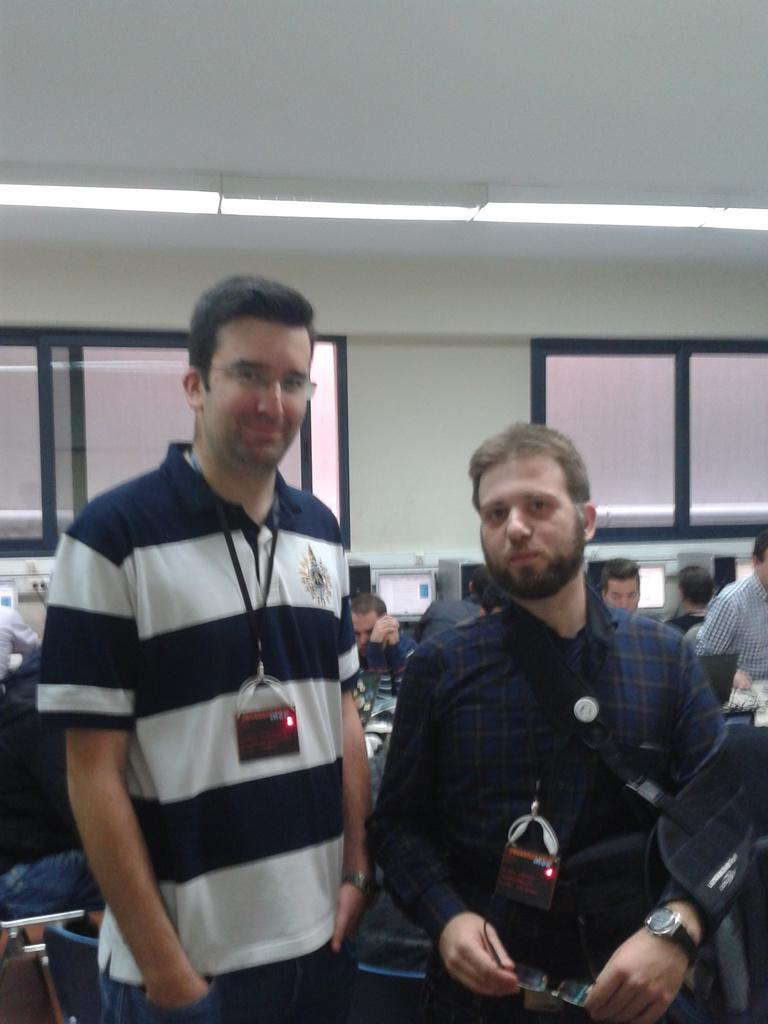What is the main subject of the image? The main subject of the image is the women standing in the center. What can be observed about the women in the image? The women are wearing ID cards. What can be seen in the background of the image? There are monitors, persons, windows, lights, and a wall in the background of the image. What type of wool is being spun by the tank in the image? There is no tank or wool present in the image. What is the end result of the process depicted in the image? The image does not depict a process with a specific end result; it simply shows women standing in the center and various elements in the background. 